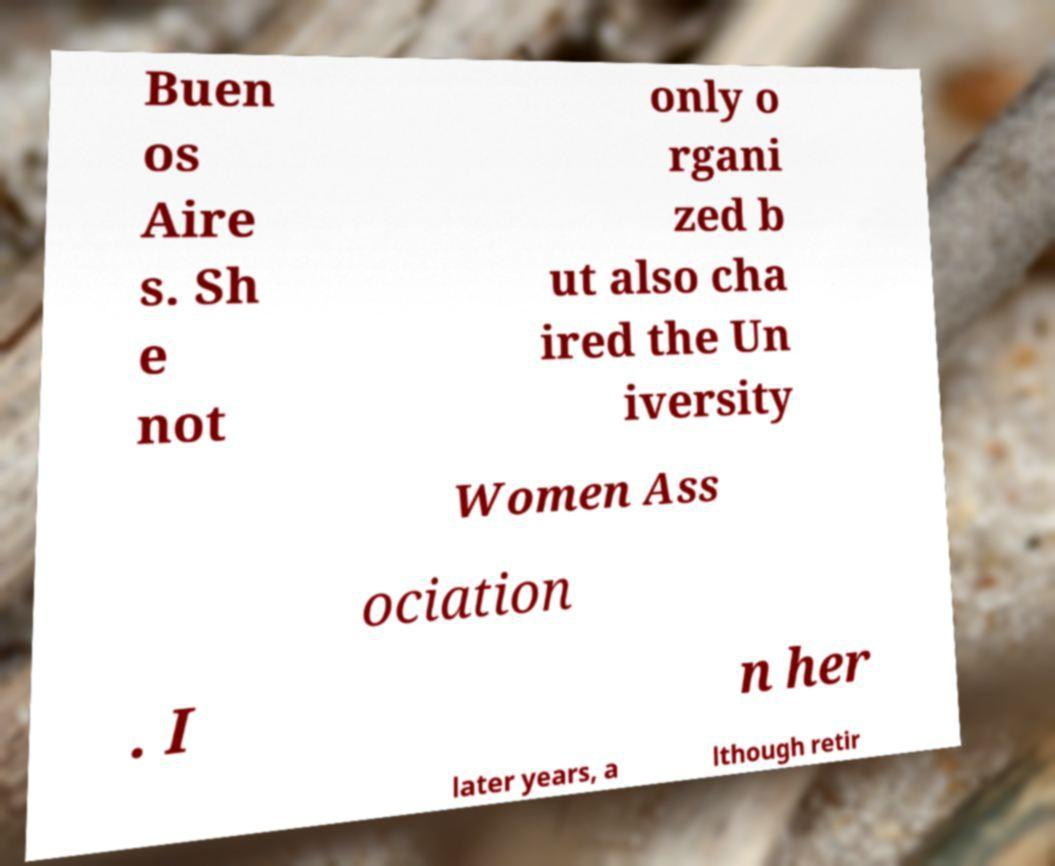What messages or text are displayed in this image? I need them in a readable, typed format. Buen os Aire s. Sh e not only o rgani zed b ut also cha ired the Un iversity Women Ass ociation . I n her later years, a lthough retir 